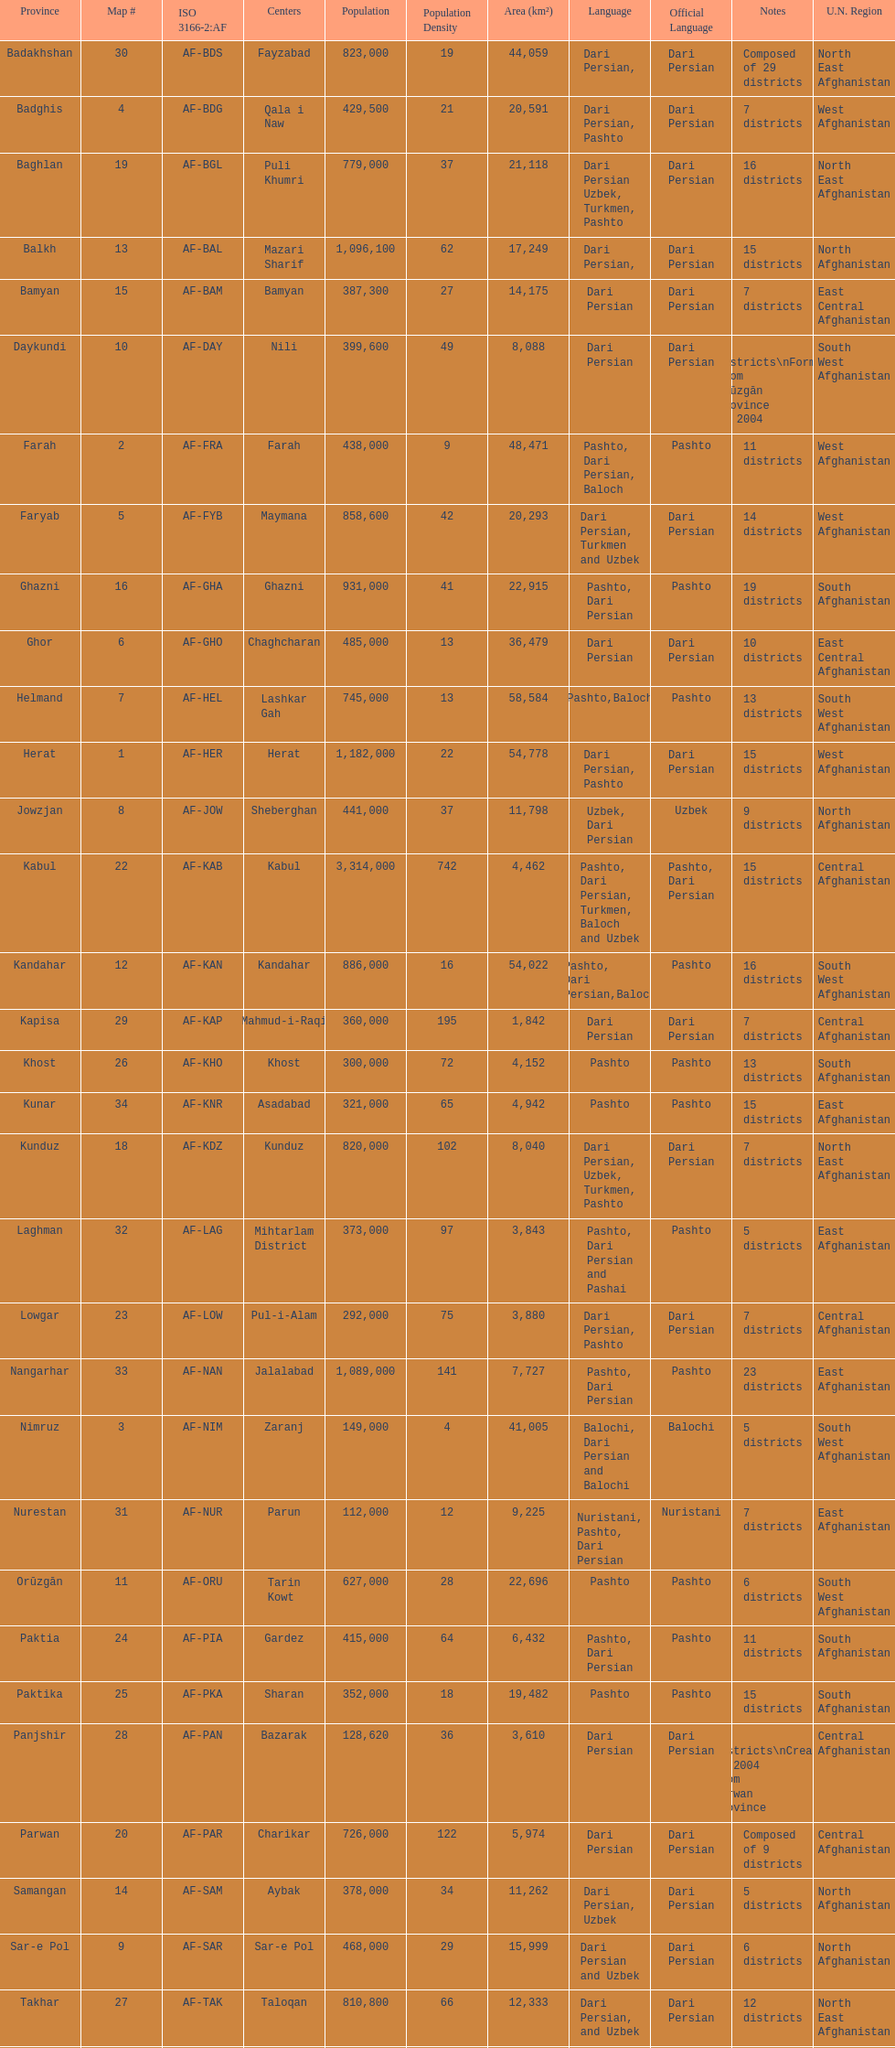Which province has the most districts? Badakhshan. 